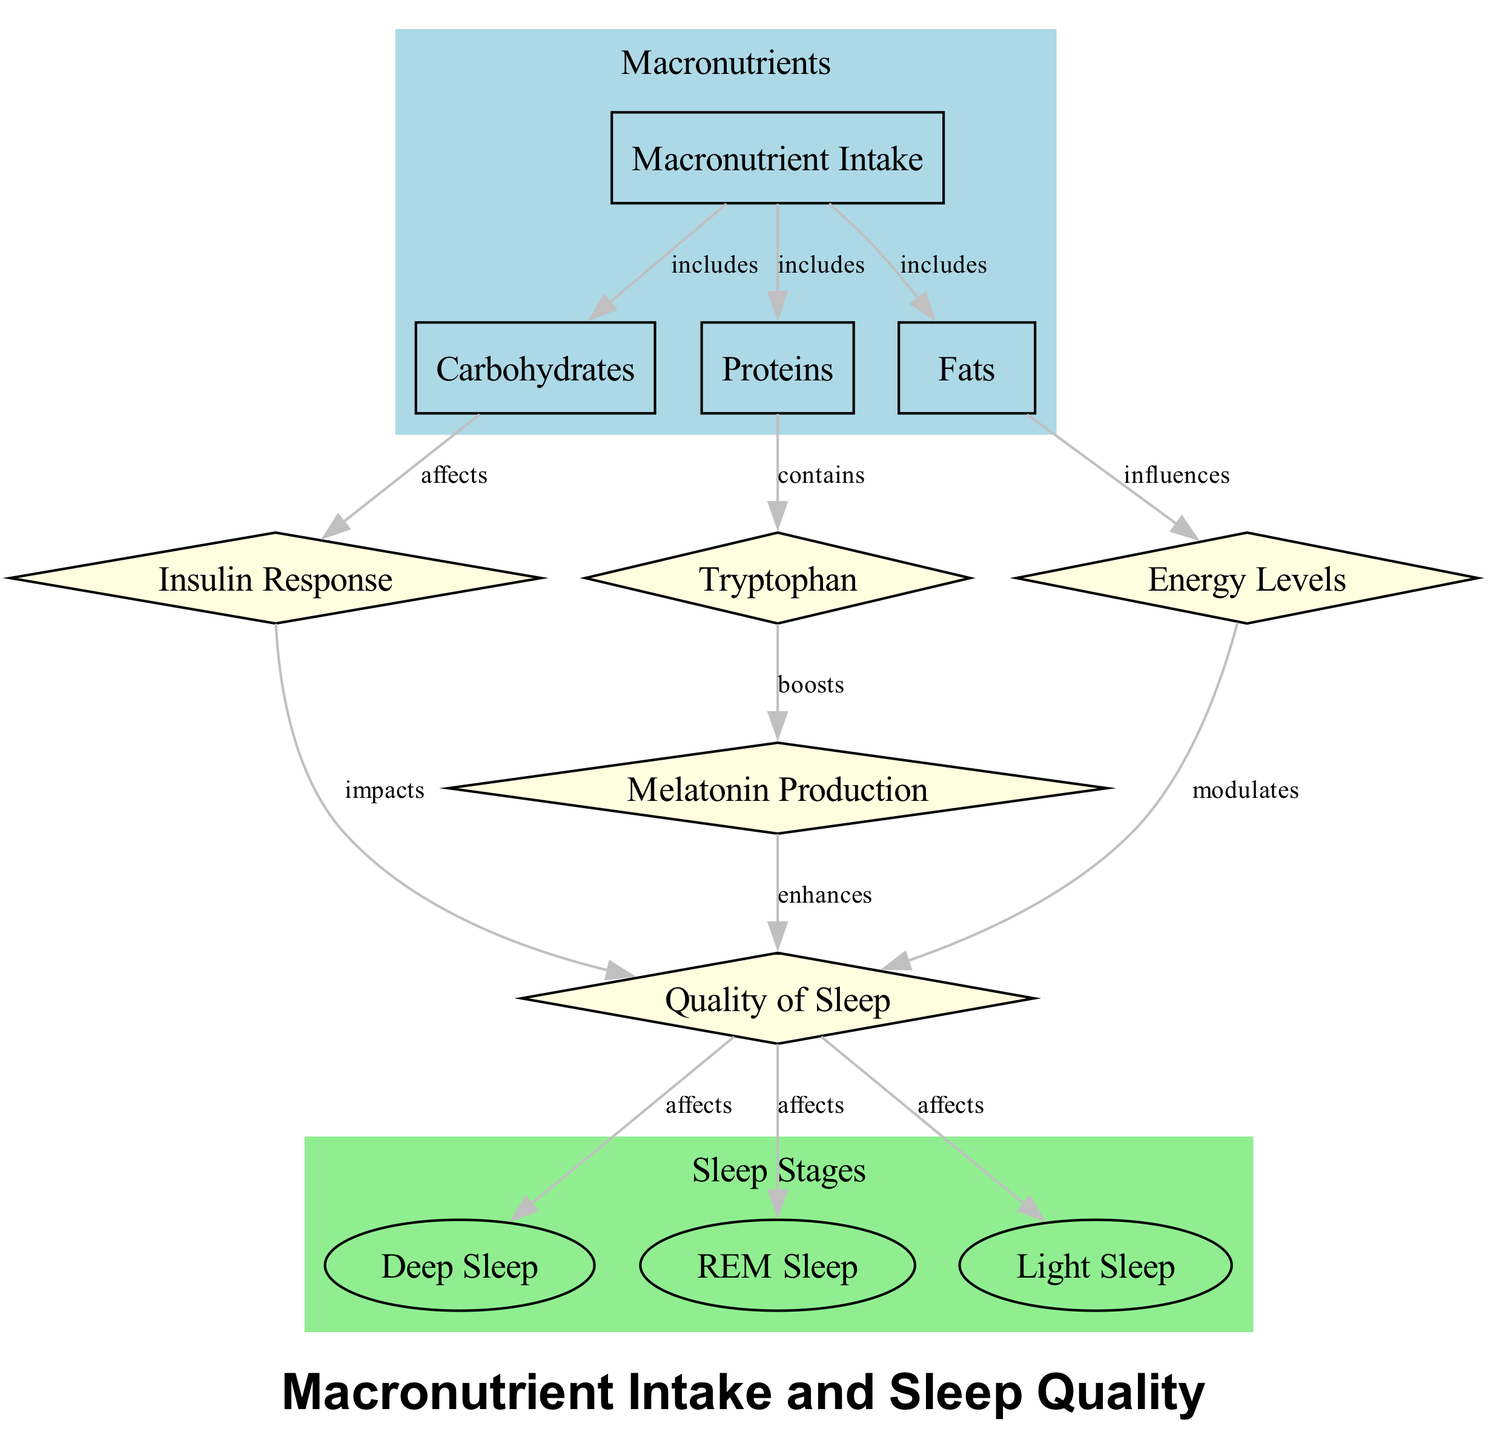What are the three types of macronutrients mentioned? The diagram specifically lists carbohydrates, proteins, and fats as the three types of macronutrients included in the macronutrient intake node.
Answer: carbohydrates, proteins, fats How does carbohydrate intake affect sleep quality? The diagram shows that carbohydrate intake affects insulin response, which impacts sleep quality, indicating a direct connection between carbohydrates and sleep quality.
Answer: insulin response What does tryptophan boost according to the diagram? The diagram indicates that tryptophan boosts melatonin production, making it a key nutrient in influencing sleep quality.
Answer: melatonin production Which sleep stage is affected by sleep quality? The diagram indicates that sleep quality affects all three sleep stages listed: light sleep, deep sleep, and REM sleep, thus directly linking overall sleep quality to these specific stages.
Answer: light sleep, deep sleep, REM sleep What influence do fats have on energy levels? The diagram illustrates that fats influence energy levels, which is a key component when considering factors that modulate sleep quality.
Answer: influences How many edges are there in total in the diagram? By counting the number of connections (edges) listed in the diagram, we can see there are 12 edges forming relationships between the nodes.
Answer: 12 Which compound enhances sleep quality? The diagram indicates that melatonin production enhances sleep quality, highlighting its importance in achieving better sleep.
Answer: melatonin production What is the relationship between proteins and sleep quality? The diagram indicates that proteins contain tryptophan, which boosts melatonin production, thus indirectly impacting sleep quality through increased melatonin levels.
Answer: boosts melatonin production How does energy level modulation relate to sleep quality? The diagram illustrates that energy levels modulate sleep quality, suggesting that maintaining balanced energy levels is essential for good sleep.
Answer: modulates 